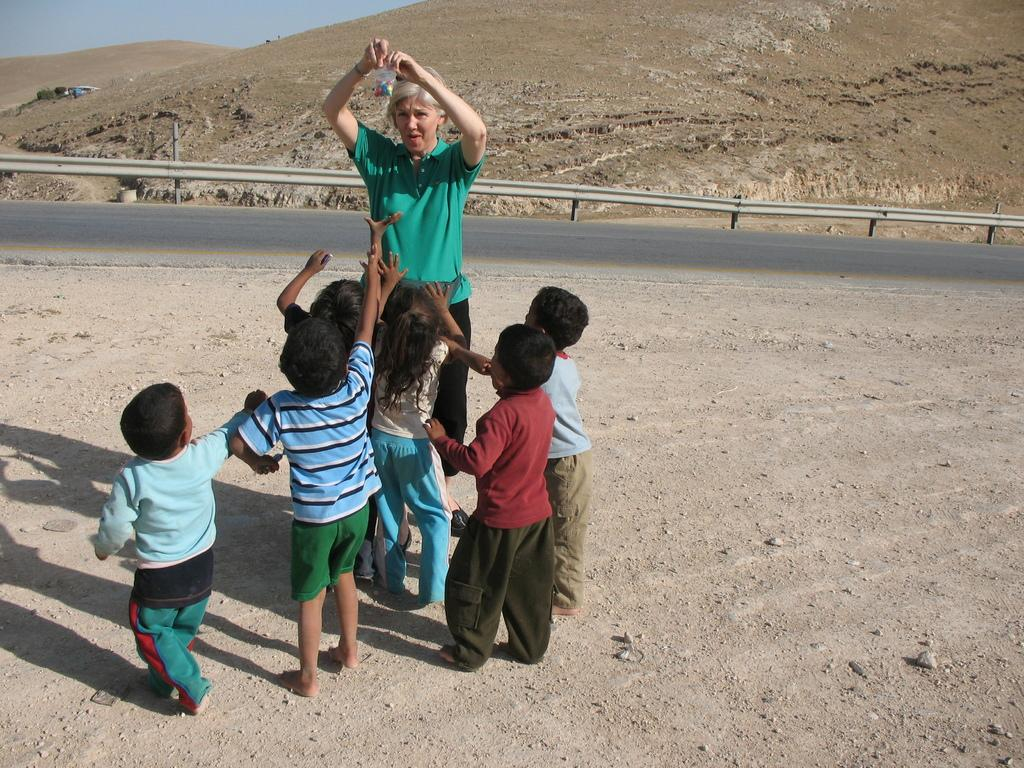How many people are in the image? There are persons standing in the image. What can be seen in the background of the image? There is a fence, a road, and mountains visible in the background of the image. How do the brothers feel about the mark on the fence in the image? There is no mention of brothers or a mark on the fence in the image, so this question cannot be answered definitively. 